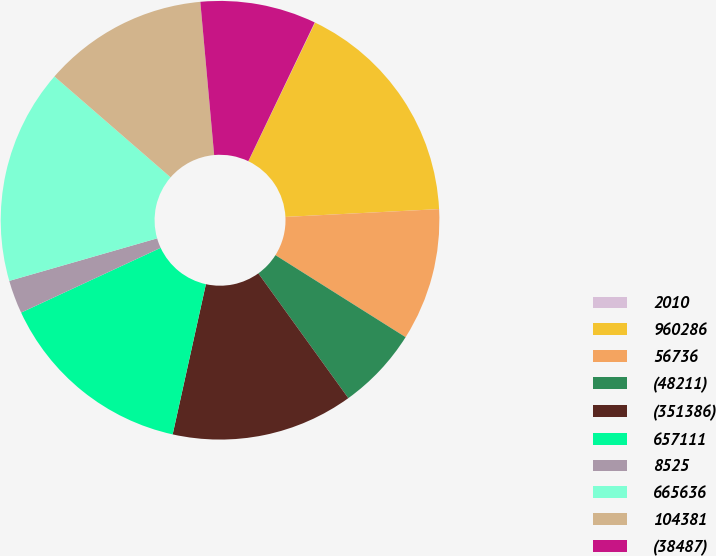<chart> <loc_0><loc_0><loc_500><loc_500><pie_chart><fcel>2010<fcel>960286<fcel>56736<fcel>(48211)<fcel>(351386)<fcel>657111<fcel>8525<fcel>665636<fcel>104381<fcel>(38487)<nl><fcel>0.03%<fcel>17.06%<fcel>9.76%<fcel>6.11%<fcel>13.41%<fcel>14.62%<fcel>2.46%<fcel>15.84%<fcel>12.19%<fcel>8.54%<nl></chart> 